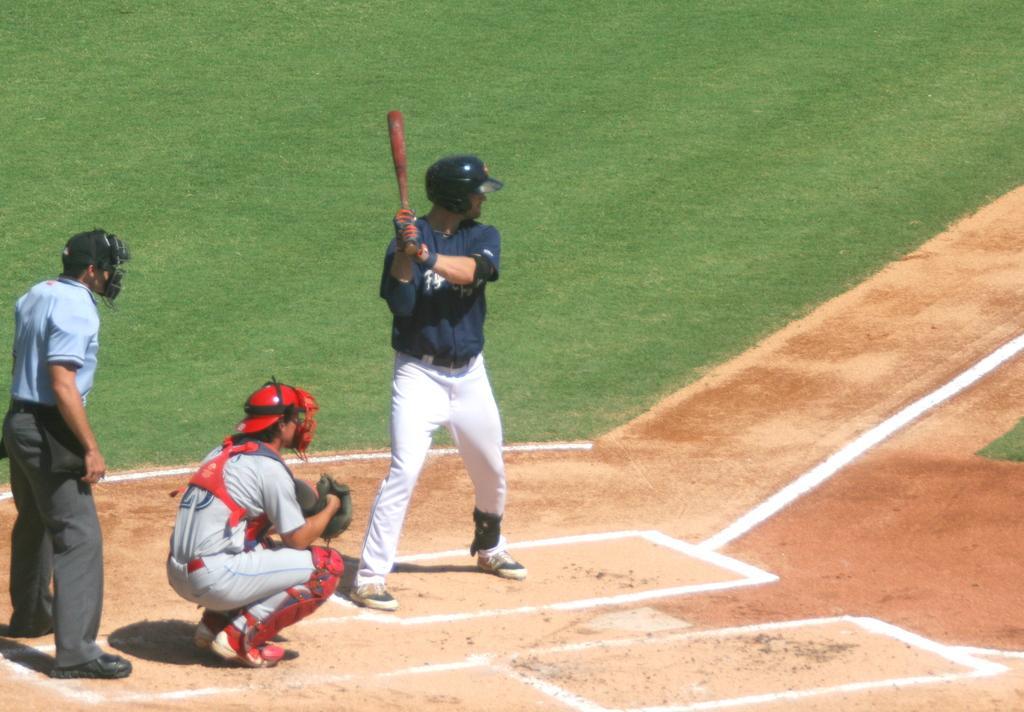Please provide a concise description of this image. In this image I can see ground and on it I can see few people. I can also see all of them are wearing helmets and two of them are wearing gloves. Here I can see he is wearing wrist band and I can see he is holding red color bat. I can also see white color lines on ground. 